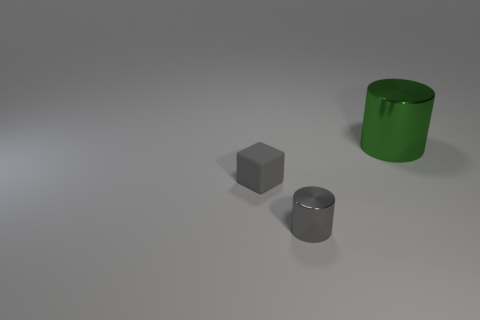Do the big thing and the gray cylinder have the same material?
Ensure brevity in your answer.  Yes. How many things are things in front of the big green metal thing or small things in front of the gray block?
Keep it short and to the point. 2. There is another tiny shiny thing that is the same shape as the green object; what is its color?
Offer a very short reply. Gray. How many metallic objects have the same color as the tiny block?
Provide a succinct answer. 1. Does the large shiny cylinder have the same color as the small metallic cylinder?
Give a very brief answer. No. How many objects are cylinders in front of the tiny rubber object or metal objects?
Give a very brief answer. 2. What is the color of the shiny thing that is in front of the object that is behind the small gray object that is behind the gray shiny cylinder?
Ensure brevity in your answer.  Gray. There is a small cylinder that is the same material as the green thing; what color is it?
Make the answer very short. Gray. How many other cylinders are the same material as the big green cylinder?
Your response must be concise. 1. There is a thing that is behind the gray matte cube; is its size the same as the tiny gray matte cube?
Offer a terse response. No. 